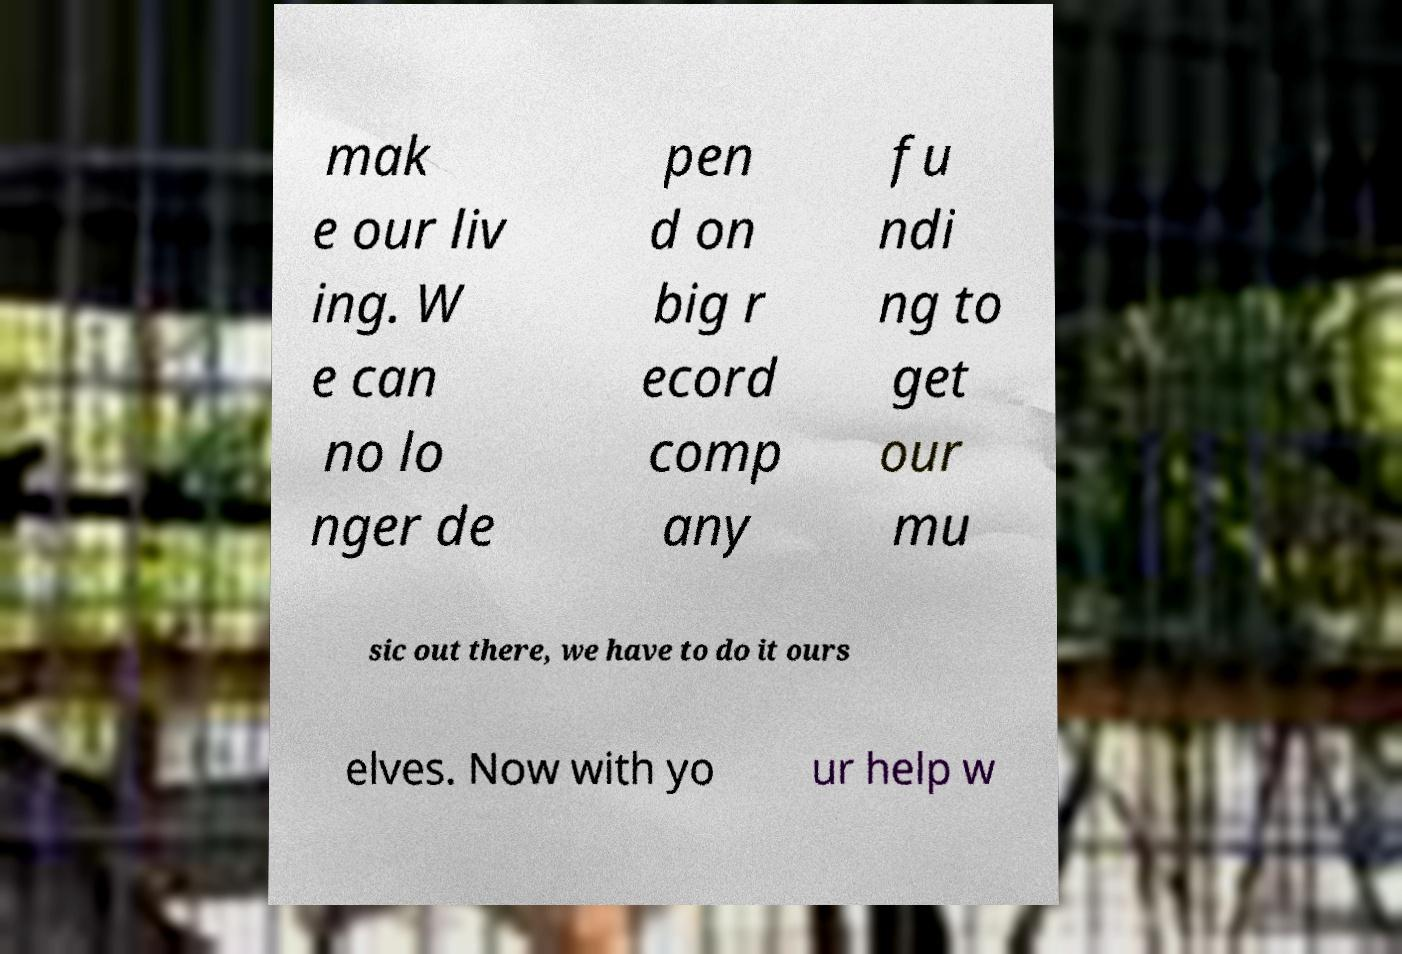Could you assist in decoding the text presented in this image and type it out clearly? mak e our liv ing. W e can no lo nger de pen d on big r ecord comp any fu ndi ng to get our mu sic out there, we have to do it ours elves. Now with yo ur help w 